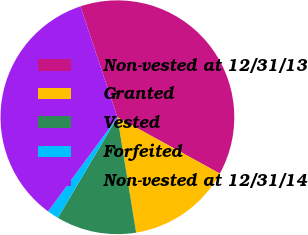Convert chart. <chart><loc_0><loc_0><loc_500><loc_500><pie_chart><fcel>Non-vested at 12/31/13<fcel>Granted<fcel>Vested<fcel>Forfeited<fcel>Non-vested at 12/31/14<nl><fcel>38.13%<fcel>14.44%<fcel>11.07%<fcel>1.59%<fcel>34.77%<nl></chart> 